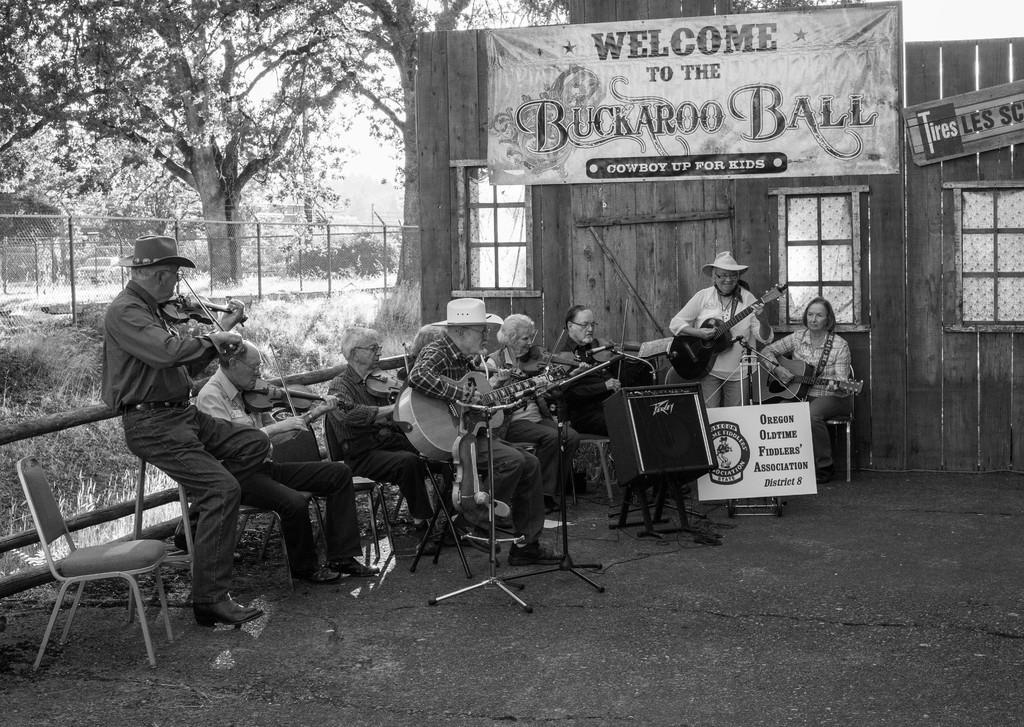What are the people in the image doing? The people in the image are playing musical instruments. What are the people sitting on while playing their instruments? The people are sitting on chairs in the image. What can be seen in the background of the image? There is a wooden house in the background of the image. What type of sign can be seen hanging from the wooden house in the image? There is no sign visible hanging from the wooden house in the image. 